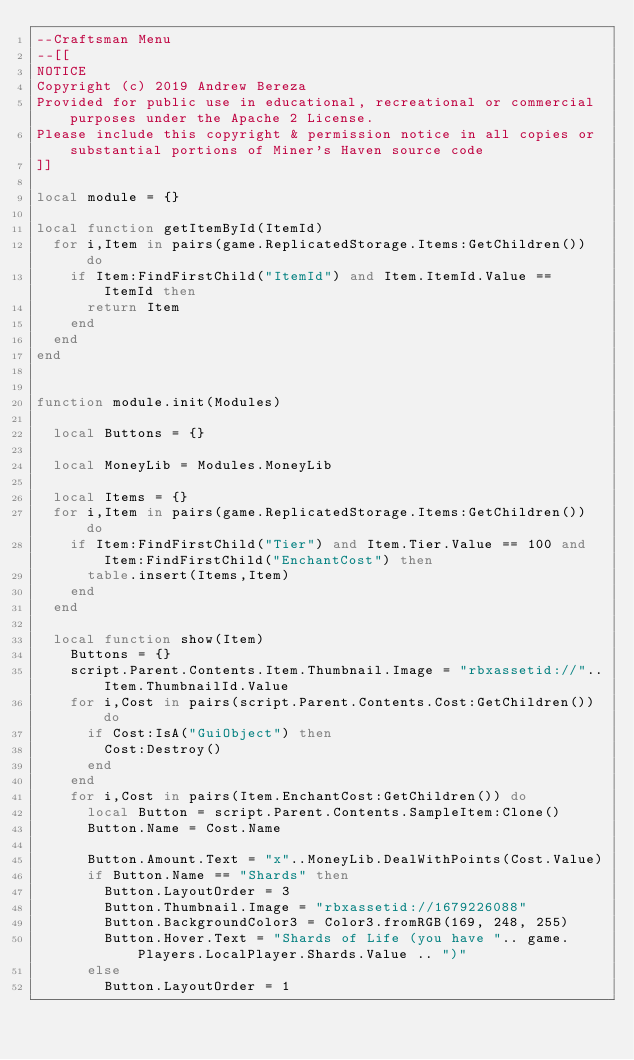Convert code to text. <code><loc_0><loc_0><loc_500><loc_500><_Lua_>--Craftsman Menu
--[[
NOTICE
Copyright (c) 2019 Andrew Bereza
Provided for public use in educational, recreational or commercial purposes under the Apache 2 License.
Please include this copyright & permission notice in all copies or substantial portions of Miner's Haven source code
]]

local module = {}

local function getItemById(ItemId)
	for i,Item in pairs(game.ReplicatedStorage.Items:GetChildren()) do
		if Item:FindFirstChild("ItemId") and Item.ItemId.Value == ItemId then
			return Item
		end
	end
end


function module.init(Modules)

	local Buttons = {}

	local MoneyLib = Modules.MoneyLib

	local Items = {}
	for i,Item in pairs(game.ReplicatedStorage.Items:GetChildren()) do
		if Item:FindFirstChild("Tier") and Item.Tier.Value == 100 and Item:FindFirstChild("EnchantCost") then
			table.insert(Items,Item)
		end
	end

	local function show(Item)
		Buttons = {}
		script.Parent.Contents.Item.Thumbnail.Image = "rbxassetid://"..Item.ThumbnailId.Value
		for i,Cost in pairs(script.Parent.Contents.Cost:GetChildren()) do
			if Cost:IsA("GuiObject") then
				Cost:Destroy()
			end
		end
		for i,Cost in pairs(Item.EnchantCost:GetChildren()) do
			local Button = script.Parent.Contents.SampleItem:Clone()
			Button.Name = Cost.Name

			Button.Amount.Text = "x"..MoneyLib.DealWithPoints(Cost.Value)
			if Button.Name == "Shards" then
				Button.LayoutOrder = 3
				Button.Thumbnail.Image = "rbxassetid://1679226088"
				Button.BackgroundColor3 = Color3.fromRGB(169, 248, 255)
				Button.Hover.Text = "Shards of Life (you have ".. game.Players.LocalPlayer.Shards.Value .. ")"
			else
				Button.LayoutOrder = 1</code> 